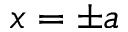Convert formula to latex. <formula><loc_0><loc_0><loc_500><loc_500>x = \pm a</formula> 